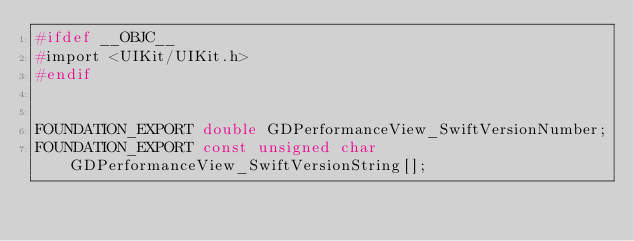<code> <loc_0><loc_0><loc_500><loc_500><_C_>#ifdef __OBJC__
#import <UIKit/UIKit.h>
#endif


FOUNDATION_EXPORT double GDPerformanceView_SwiftVersionNumber;
FOUNDATION_EXPORT const unsigned char GDPerformanceView_SwiftVersionString[];

</code> 